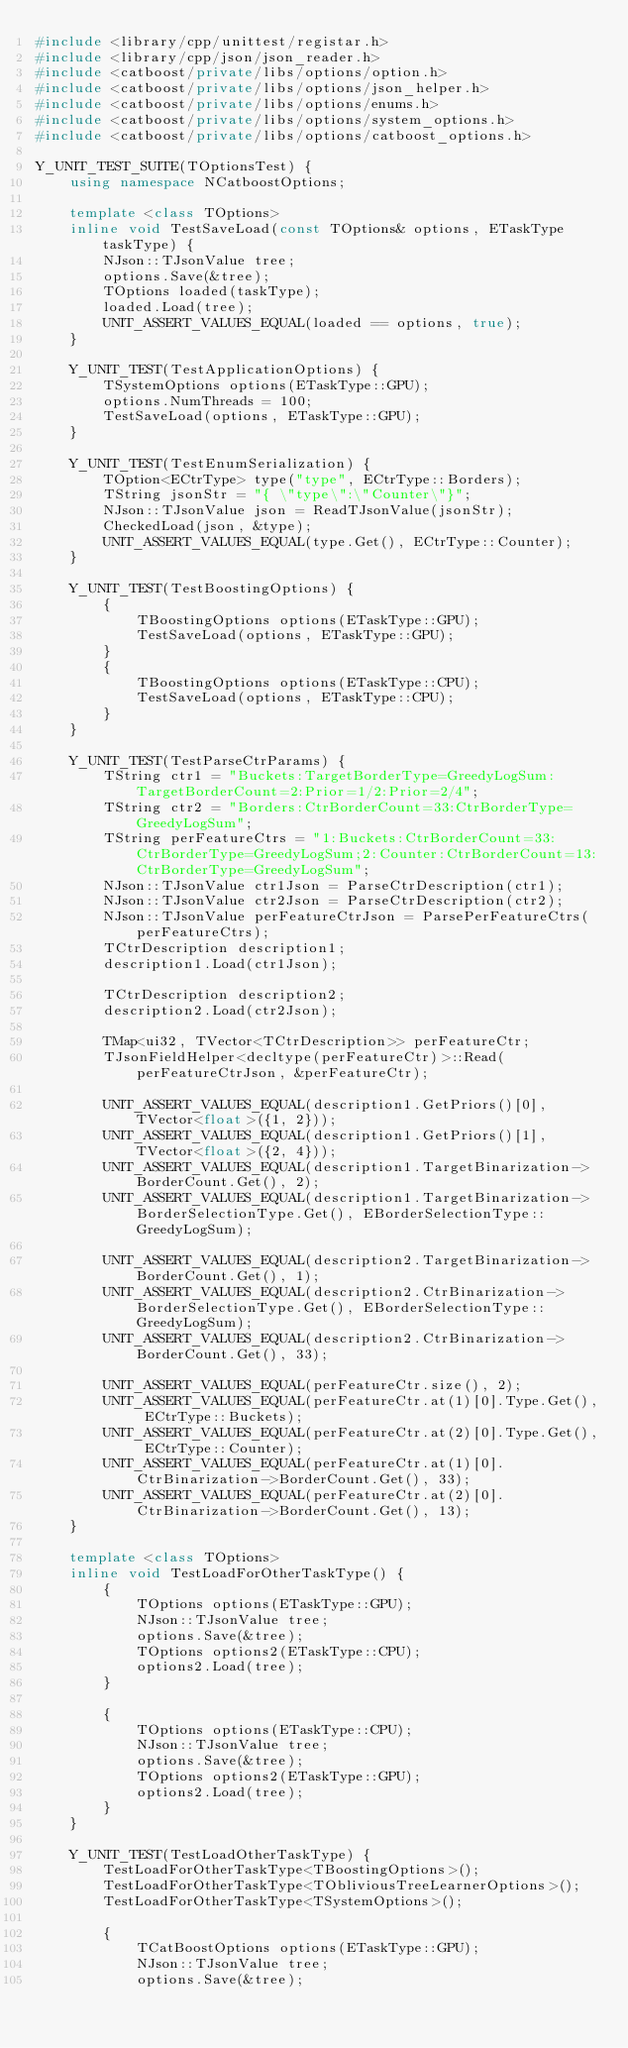<code> <loc_0><loc_0><loc_500><loc_500><_C++_>#include <library/cpp/unittest/registar.h>
#include <library/cpp/json/json_reader.h>
#include <catboost/private/libs/options/option.h>
#include <catboost/private/libs/options/json_helper.h>
#include <catboost/private/libs/options/enums.h>
#include <catboost/private/libs/options/system_options.h>
#include <catboost/private/libs/options/catboost_options.h>

Y_UNIT_TEST_SUITE(TOptionsTest) {
    using namespace NCatboostOptions;

    template <class TOptions>
    inline void TestSaveLoad(const TOptions& options, ETaskType taskType) {
        NJson::TJsonValue tree;
        options.Save(&tree);
        TOptions loaded(taskType);
        loaded.Load(tree);
        UNIT_ASSERT_VALUES_EQUAL(loaded == options, true);
    }

    Y_UNIT_TEST(TestApplicationOptions) {
        TSystemOptions options(ETaskType::GPU);
        options.NumThreads = 100;
        TestSaveLoad(options, ETaskType::GPU);
    }

    Y_UNIT_TEST(TestEnumSerialization) {
        TOption<ECtrType> type("type", ECtrType::Borders);
        TString jsonStr = "{ \"type\":\"Counter\"}";
        NJson::TJsonValue json = ReadTJsonValue(jsonStr);
        CheckedLoad(json, &type);
        UNIT_ASSERT_VALUES_EQUAL(type.Get(), ECtrType::Counter);
    }

    Y_UNIT_TEST(TestBoostingOptions) {
        {
            TBoostingOptions options(ETaskType::GPU);
            TestSaveLoad(options, ETaskType::GPU);
        }
        {
            TBoostingOptions options(ETaskType::CPU);
            TestSaveLoad(options, ETaskType::CPU);
        }
    }

    Y_UNIT_TEST(TestParseCtrParams) {
        TString ctr1 = "Buckets:TargetBorderType=GreedyLogSum:TargetBorderCount=2:Prior=1/2:Prior=2/4";
        TString ctr2 = "Borders:CtrBorderCount=33:CtrBorderType=GreedyLogSum";
        TString perFeatureCtrs = "1:Buckets:CtrBorderCount=33:CtrBorderType=GreedyLogSum;2:Counter:CtrBorderCount=13:CtrBorderType=GreedyLogSum";
        NJson::TJsonValue ctr1Json = ParseCtrDescription(ctr1);
        NJson::TJsonValue ctr2Json = ParseCtrDescription(ctr2);
        NJson::TJsonValue perFeatureCtrJson = ParsePerFeatureCtrs(perFeatureCtrs);
        TCtrDescription description1;
        description1.Load(ctr1Json);

        TCtrDescription description2;
        description2.Load(ctr2Json);

        TMap<ui32, TVector<TCtrDescription>> perFeatureCtr;
        TJsonFieldHelper<decltype(perFeatureCtr)>::Read(perFeatureCtrJson, &perFeatureCtr);

        UNIT_ASSERT_VALUES_EQUAL(description1.GetPriors()[0], TVector<float>({1, 2}));
        UNIT_ASSERT_VALUES_EQUAL(description1.GetPriors()[1], TVector<float>({2, 4}));
        UNIT_ASSERT_VALUES_EQUAL(description1.TargetBinarization->BorderCount.Get(), 2);
        UNIT_ASSERT_VALUES_EQUAL(description1.TargetBinarization->BorderSelectionType.Get(), EBorderSelectionType::GreedyLogSum);

        UNIT_ASSERT_VALUES_EQUAL(description2.TargetBinarization->BorderCount.Get(), 1);
        UNIT_ASSERT_VALUES_EQUAL(description2.CtrBinarization->BorderSelectionType.Get(), EBorderSelectionType::GreedyLogSum);
        UNIT_ASSERT_VALUES_EQUAL(description2.CtrBinarization->BorderCount.Get(), 33);

        UNIT_ASSERT_VALUES_EQUAL(perFeatureCtr.size(), 2);
        UNIT_ASSERT_VALUES_EQUAL(perFeatureCtr.at(1)[0].Type.Get(), ECtrType::Buckets);
        UNIT_ASSERT_VALUES_EQUAL(perFeatureCtr.at(2)[0].Type.Get(), ECtrType::Counter);
        UNIT_ASSERT_VALUES_EQUAL(perFeatureCtr.at(1)[0].CtrBinarization->BorderCount.Get(), 33);
        UNIT_ASSERT_VALUES_EQUAL(perFeatureCtr.at(2)[0].CtrBinarization->BorderCount.Get(), 13);
    }

    template <class TOptions>
    inline void TestLoadForOtherTaskType() {
        {
            TOptions options(ETaskType::GPU);
            NJson::TJsonValue tree;
            options.Save(&tree);
            TOptions options2(ETaskType::CPU);
            options2.Load(tree);
        }

        {
            TOptions options(ETaskType::CPU);
            NJson::TJsonValue tree;
            options.Save(&tree);
            TOptions options2(ETaskType::GPU);
            options2.Load(tree);
        }
    }

    Y_UNIT_TEST(TestLoadOtherTaskType) {
        TestLoadForOtherTaskType<TBoostingOptions>();
        TestLoadForOtherTaskType<TObliviousTreeLearnerOptions>();
        TestLoadForOtherTaskType<TSystemOptions>();

        {
            TCatBoostOptions options(ETaskType::GPU);
            NJson::TJsonValue tree;
            options.Save(&tree);</code> 